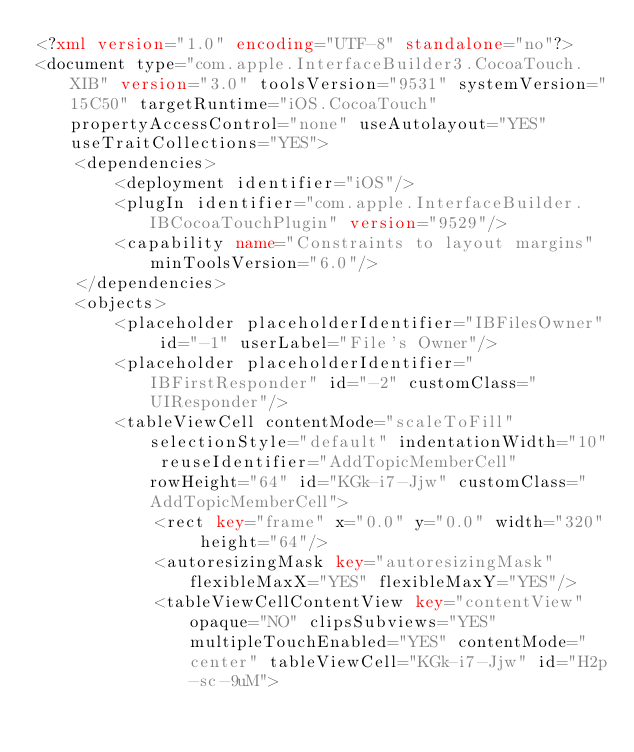Convert code to text. <code><loc_0><loc_0><loc_500><loc_500><_XML_><?xml version="1.0" encoding="UTF-8" standalone="no"?>
<document type="com.apple.InterfaceBuilder3.CocoaTouch.XIB" version="3.0" toolsVersion="9531" systemVersion="15C50" targetRuntime="iOS.CocoaTouch" propertyAccessControl="none" useAutolayout="YES" useTraitCollections="YES">
    <dependencies>
        <deployment identifier="iOS"/>
        <plugIn identifier="com.apple.InterfaceBuilder.IBCocoaTouchPlugin" version="9529"/>
        <capability name="Constraints to layout margins" minToolsVersion="6.0"/>
    </dependencies>
    <objects>
        <placeholder placeholderIdentifier="IBFilesOwner" id="-1" userLabel="File's Owner"/>
        <placeholder placeholderIdentifier="IBFirstResponder" id="-2" customClass="UIResponder"/>
        <tableViewCell contentMode="scaleToFill" selectionStyle="default" indentationWidth="10" reuseIdentifier="AddTopicMemberCell" rowHeight="64" id="KGk-i7-Jjw" customClass="AddTopicMemberCell">
            <rect key="frame" x="0.0" y="0.0" width="320" height="64"/>
            <autoresizingMask key="autoresizingMask" flexibleMaxX="YES" flexibleMaxY="YES"/>
            <tableViewCellContentView key="contentView" opaque="NO" clipsSubviews="YES" multipleTouchEnabled="YES" contentMode="center" tableViewCell="KGk-i7-Jjw" id="H2p-sc-9uM"></code> 